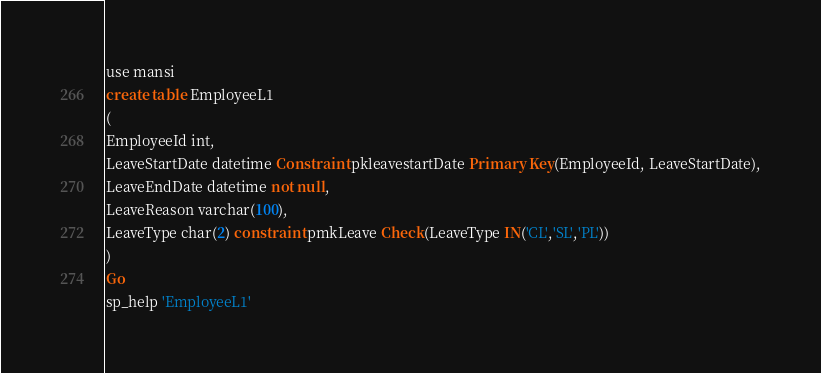<code> <loc_0><loc_0><loc_500><loc_500><_SQL_>use mansi
create table EmployeeL1
(
EmployeeId int,
LeaveStartDate datetime Constraint pkleavestartDate Primary Key(EmployeeId, LeaveStartDate),
LeaveEndDate datetime not null,
LeaveReason varchar(100),
LeaveType char(2) constraint pmkLeave Check(LeaveType IN('CL','SL','PL'))
)
Go
sp_help 'EmployeeL1'</code> 